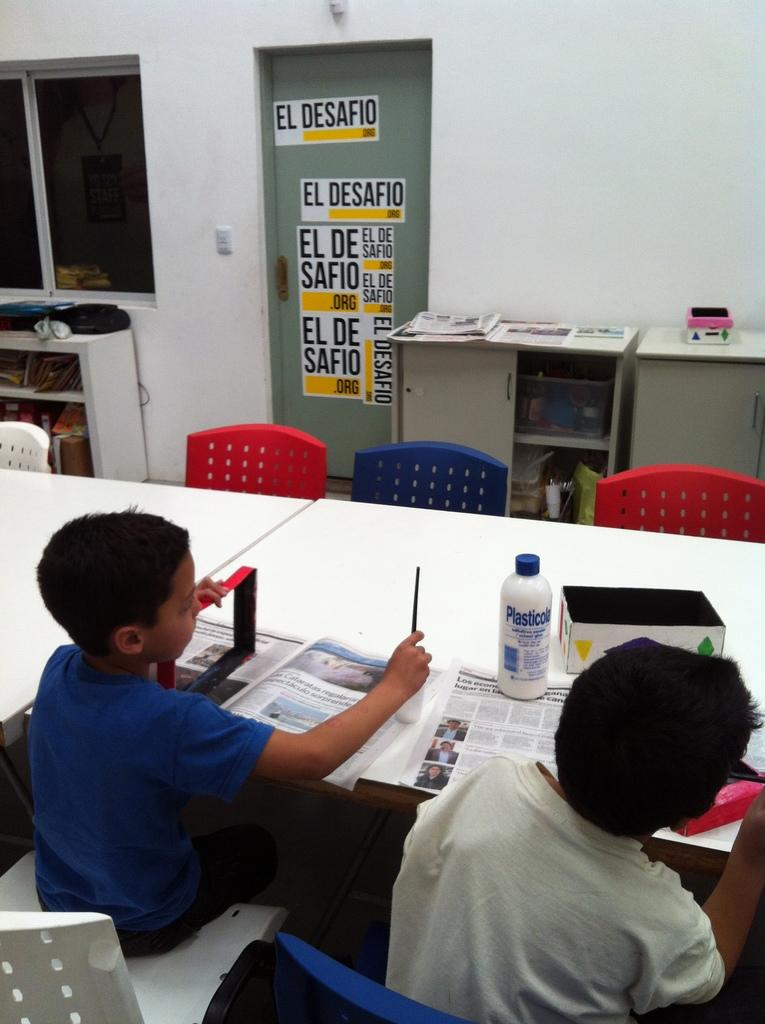<image>
Share a concise interpretation of the image provided. the words el desafio that are on a board 